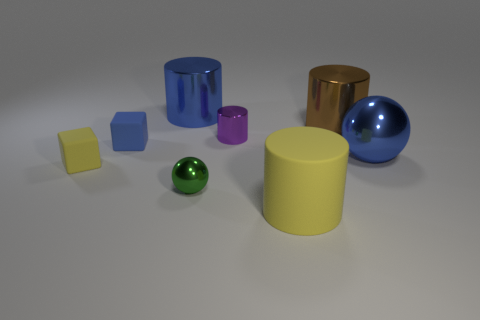Subtract all big matte cylinders. How many cylinders are left? 3 Add 2 big metal objects. How many objects exist? 10 Subtract all spheres. How many objects are left? 6 Subtract all brown cylinders. How many cylinders are left? 3 Subtract all gray cylinders. Subtract all yellow spheres. How many cylinders are left? 4 Subtract all blue metallic balls. Subtract all matte objects. How many objects are left? 4 Add 4 purple things. How many purple things are left? 5 Add 4 large spheres. How many large spheres exist? 5 Subtract 0 gray blocks. How many objects are left? 8 Subtract 1 cylinders. How many cylinders are left? 3 